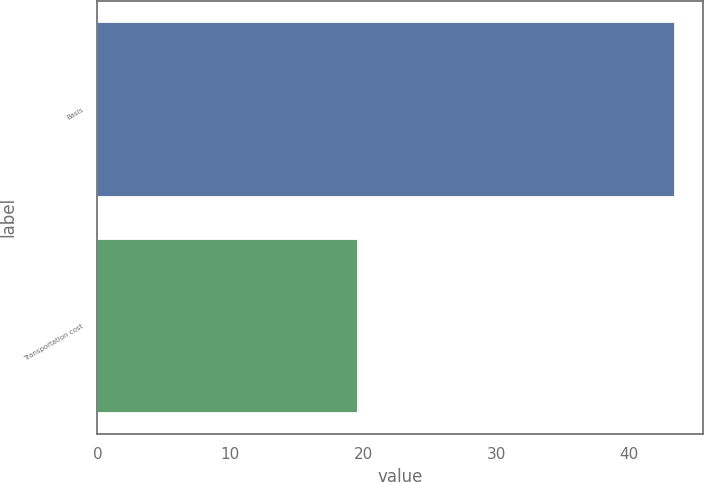Convert chart to OTSL. <chart><loc_0><loc_0><loc_500><loc_500><bar_chart><fcel>Basis<fcel>Transportation cost<nl><fcel>43.4<fcel>19.5<nl></chart> 